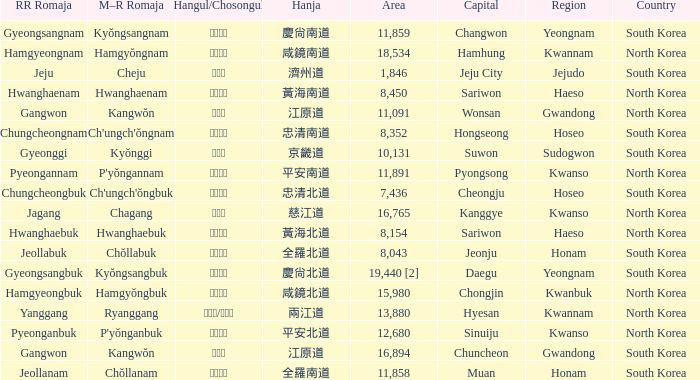Which capital has a Hangul of 경상남도? Changwon. 